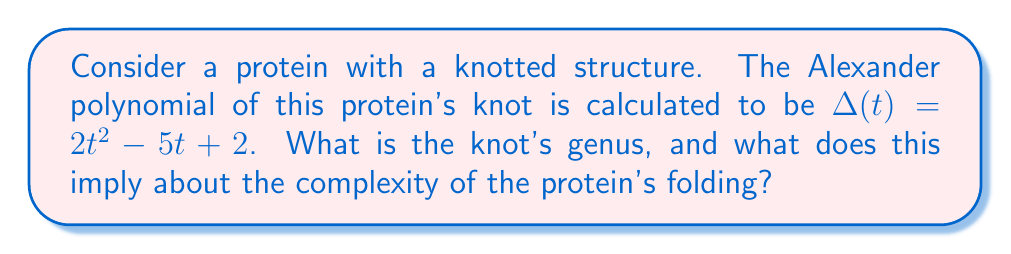Teach me how to tackle this problem. To solve this problem, we'll follow these steps:

1) The Alexander polynomial is a knot invariant that can provide information about the knot's structure. One important property is that the degree of the Alexander polynomial is related to the genus of the knot.

2) The relation between the degree of the Alexander polynomial and the knot genus is given by:

   $$\text{deg}(\Delta(t)) \leq 2g$$

   where $g$ is the genus of the knot.

3) In this case, the Alexander polynomial is $\Delta(t) = 2t^2 - 5t + 2$. The degree of this polynomial is 2.

4) Using the inequality from step 2:

   $$2 \leq 2g$$

5) Solving for $g$:

   $$g \geq 1$$

6) Since the genus must be a non-negative integer, the smallest possible value for $g$ that satisfies this inequality is 1.

7) The genus of a knot is a measure of its complexity. A genus of 1 indicates that this is not a trivial knot (which would have a genus of 0), but it's also not extremely complex.

8) In the context of protein folding, a knotted structure with a genus of 1 suggests a moderately complex folding pattern. This could imply:
   - The protein has a non-trivial tertiary structure.
   - The folding process likely involves specific interactions to achieve this knotted state.
   - The knot might play a role in the protein's function or stability.
Answer: Genus = 1; moderately complex folding 